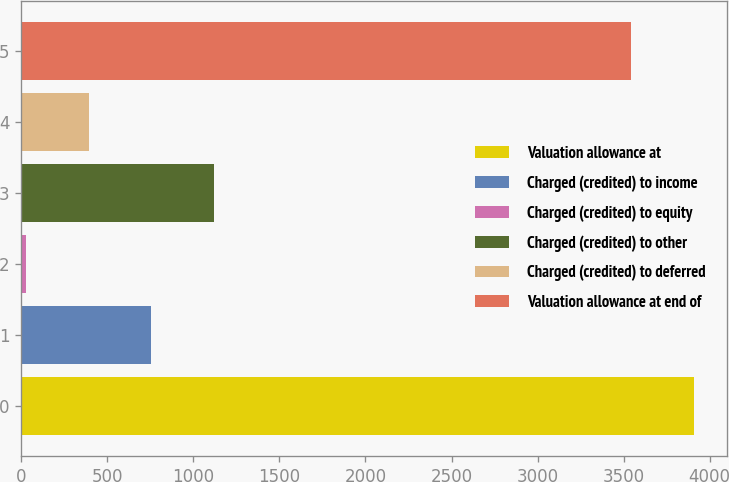Convert chart. <chart><loc_0><loc_0><loc_500><loc_500><bar_chart><fcel>Valuation allowance at<fcel>Charged (credited) to income<fcel>Charged (credited) to equity<fcel>Charged (credited) to other<fcel>Charged (credited) to deferred<fcel>Valuation allowance at end of<nl><fcel>3906.4<fcel>756.8<fcel>28<fcel>1121.2<fcel>392.4<fcel>3542<nl></chart> 